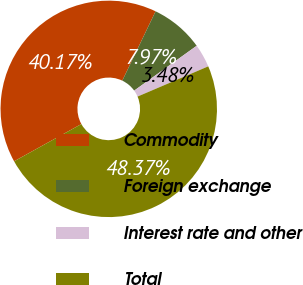Convert chart. <chart><loc_0><loc_0><loc_500><loc_500><pie_chart><fcel>Commodity<fcel>Foreign exchange<fcel>Interest rate and other<fcel>Total<nl><fcel>40.17%<fcel>7.97%<fcel>3.48%<fcel>48.37%<nl></chart> 